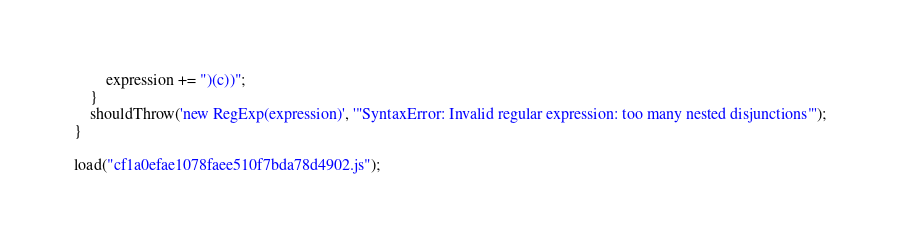<code> <loc_0><loc_0><loc_500><loc_500><_JavaScript_>        expression += ")(c))";
    }
    shouldThrow('new RegExp(expression)', '"SyntaxError: Invalid regular expression: too many nested disjunctions"');
}

load("cf1a0efae1078faee510f7bda78d4902.js");
</code> 